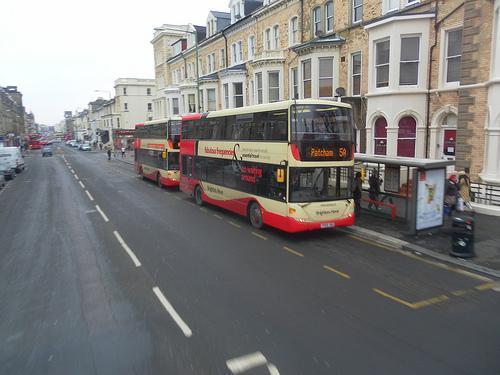How many buses are parked in the lines?
Give a very brief answer. 2. How many people have walked past the bus?
Give a very brief answer. 2. 